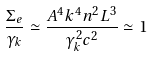<formula> <loc_0><loc_0><loc_500><loc_500>\frac { \Sigma _ { e } } { \gamma _ { k } } \simeq \frac { A ^ { 4 } k ^ { 4 } n ^ { 2 } L ^ { 3 } } { \gamma _ { k } ^ { 2 } c ^ { 2 } } \simeq 1</formula> 